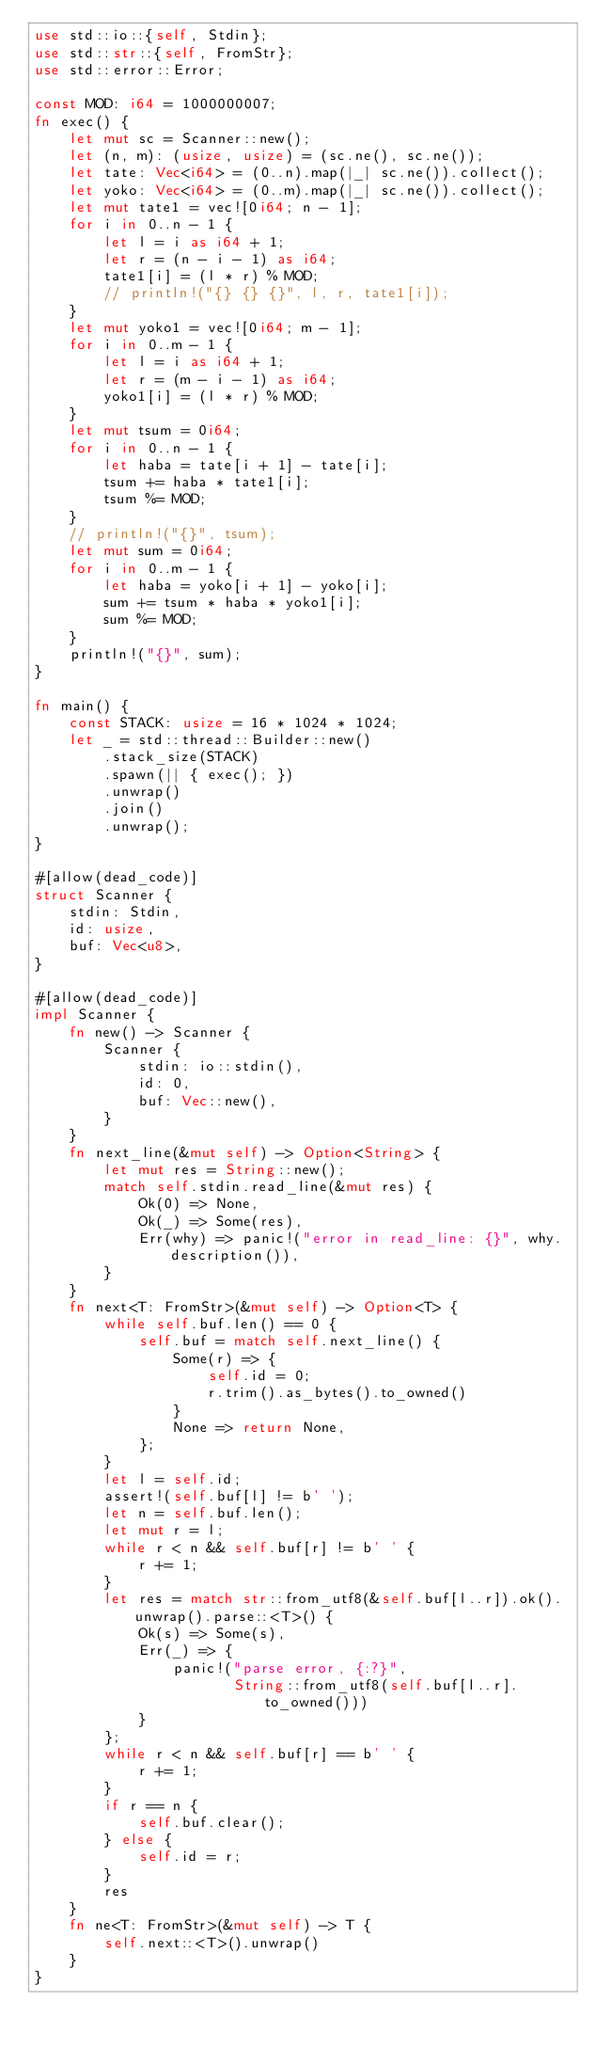<code> <loc_0><loc_0><loc_500><loc_500><_Rust_>use std::io::{self, Stdin};
use std::str::{self, FromStr};
use std::error::Error;

const MOD: i64 = 1000000007;
fn exec() {
    let mut sc = Scanner::new();
    let (n, m): (usize, usize) = (sc.ne(), sc.ne());
    let tate: Vec<i64> = (0..n).map(|_| sc.ne()).collect();
    let yoko: Vec<i64> = (0..m).map(|_| sc.ne()).collect();
    let mut tate1 = vec![0i64; n - 1];
    for i in 0..n - 1 {
        let l = i as i64 + 1;
        let r = (n - i - 1) as i64;
        tate1[i] = (l * r) % MOD;
        // println!("{} {} {}", l, r, tate1[i]);
    }
    let mut yoko1 = vec![0i64; m - 1];
    for i in 0..m - 1 {
        let l = i as i64 + 1;
        let r = (m - i - 1) as i64;
        yoko1[i] = (l * r) % MOD;
    }
    let mut tsum = 0i64;
    for i in 0..n - 1 {
        let haba = tate[i + 1] - tate[i];
        tsum += haba * tate1[i];
        tsum %= MOD;
    }
    // println!("{}", tsum);
    let mut sum = 0i64;
    for i in 0..m - 1 {
        let haba = yoko[i + 1] - yoko[i];
        sum += tsum * haba * yoko1[i];
        sum %= MOD;
    }
    println!("{}", sum);
}

fn main() {
    const STACK: usize = 16 * 1024 * 1024;
    let _ = std::thread::Builder::new()
        .stack_size(STACK)
        .spawn(|| { exec(); })
        .unwrap()
        .join()
        .unwrap();
}

#[allow(dead_code)]
struct Scanner {
    stdin: Stdin,
    id: usize,
    buf: Vec<u8>,
}

#[allow(dead_code)]
impl Scanner {
    fn new() -> Scanner {
        Scanner {
            stdin: io::stdin(),
            id: 0,
            buf: Vec::new(),
        }
    }
    fn next_line(&mut self) -> Option<String> {
        let mut res = String::new();
        match self.stdin.read_line(&mut res) {
            Ok(0) => None,
            Ok(_) => Some(res),
            Err(why) => panic!("error in read_line: {}", why.description()),
        }
    }
    fn next<T: FromStr>(&mut self) -> Option<T> {
        while self.buf.len() == 0 {
            self.buf = match self.next_line() {
                Some(r) => {
                    self.id = 0;
                    r.trim().as_bytes().to_owned()
                }
                None => return None,
            };
        }
        let l = self.id;
        assert!(self.buf[l] != b' ');
        let n = self.buf.len();
        let mut r = l;
        while r < n && self.buf[r] != b' ' {
            r += 1;
        }
        let res = match str::from_utf8(&self.buf[l..r]).ok().unwrap().parse::<T>() {
            Ok(s) => Some(s),
            Err(_) => {
                panic!("parse error, {:?}",
                       String::from_utf8(self.buf[l..r].to_owned()))
            }
        };
        while r < n && self.buf[r] == b' ' {
            r += 1;
        }
        if r == n {
            self.buf.clear();
        } else {
            self.id = r;
        }
        res
    }
    fn ne<T: FromStr>(&mut self) -> T {
        self.next::<T>().unwrap()
    }
}
</code> 